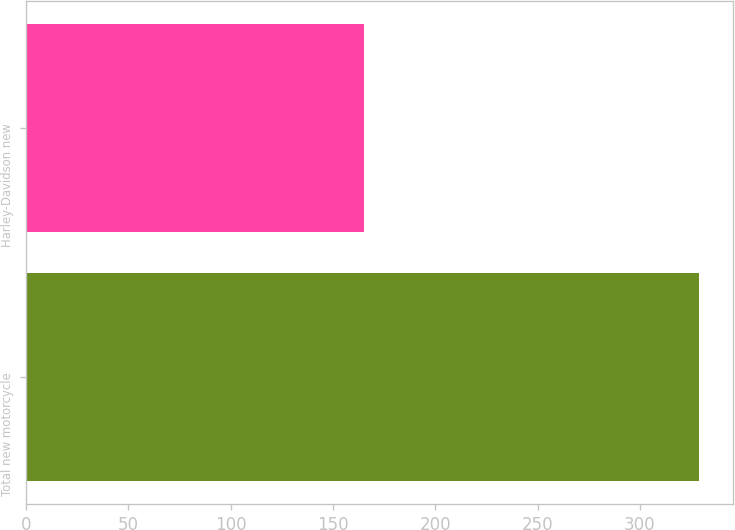<chart> <loc_0><loc_0><loc_500><loc_500><bar_chart><fcel>Total new motorcycle<fcel>Harley-Davidson new<nl><fcel>328.8<fcel>165.1<nl></chart> 